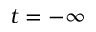Convert formula to latex. <formula><loc_0><loc_0><loc_500><loc_500>t = - \infty</formula> 